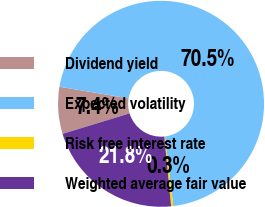Convert chart. <chart><loc_0><loc_0><loc_500><loc_500><pie_chart><fcel>Dividend yield<fcel>Expected volatility<fcel>Risk free interest rate<fcel>Weighted average fair value<nl><fcel>7.36%<fcel>70.46%<fcel>0.34%<fcel>21.84%<nl></chart> 